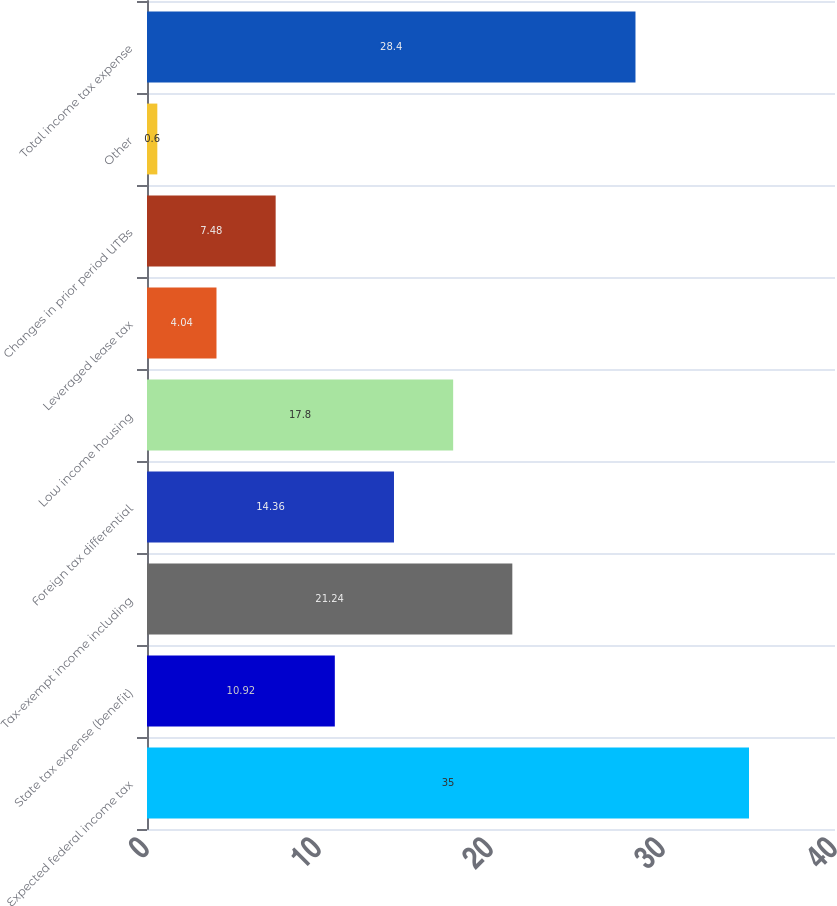<chart> <loc_0><loc_0><loc_500><loc_500><bar_chart><fcel>Expected federal income tax<fcel>State tax expense (benefit)<fcel>Tax-exempt income including<fcel>Foreign tax differential<fcel>Low income housing<fcel>Leveraged lease tax<fcel>Changes in prior period UTBs<fcel>Other<fcel>Total income tax expense<nl><fcel>35<fcel>10.92<fcel>21.24<fcel>14.36<fcel>17.8<fcel>4.04<fcel>7.48<fcel>0.6<fcel>28.4<nl></chart> 